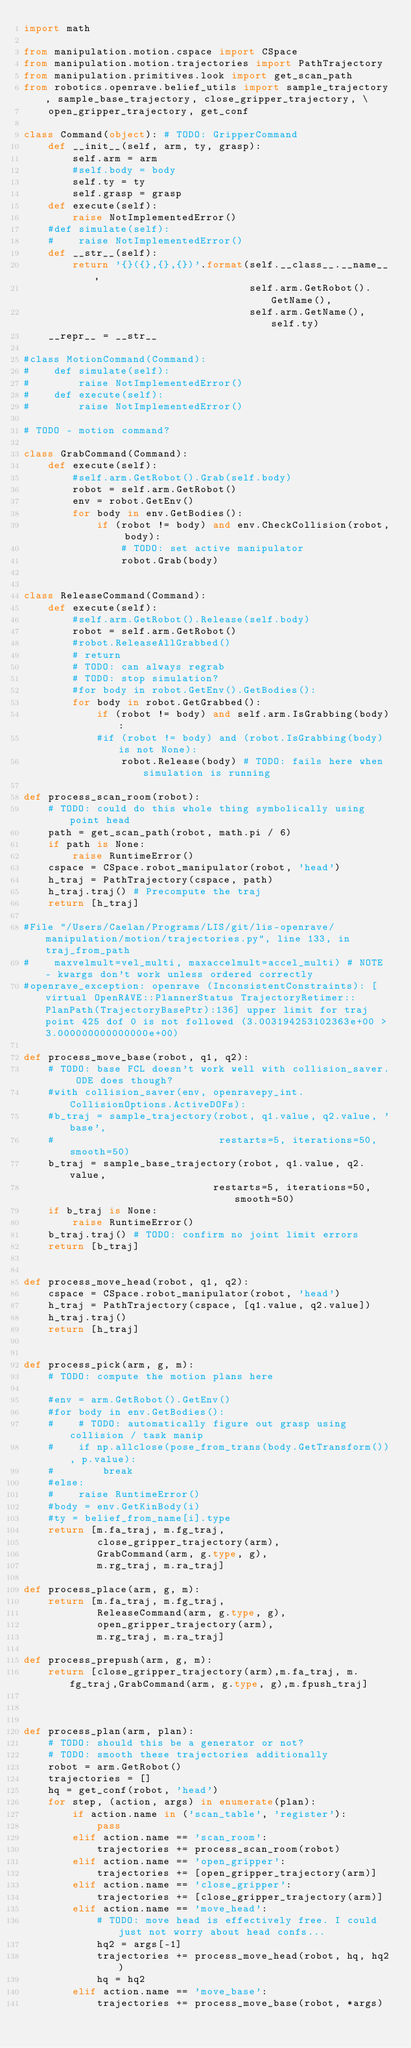<code> <loc_0><loc_0><loc_500><loc_500><_Python_>import math

from manipulation.motion.cspace import CSpace
from manipulation.motion.trajectories import PathTrajectory
from manipulation.primitives.look import get_scan_path
from robotics.openrave.belief_utils import sample_trajectory, sample_base_trajectory, close_gripper_trajectory, \
    open_gripper_trajectory, get_conf

class Command(object): # TODO: GripperCommand
    def __init__(self, arm, ty, grasp):
        self.arm = arm
        #self.body = body
        self.ty = ty
        self.grasp = grasp
    def execute(self):
        raise NotImplementedError()
    #def simulate(self):
    #    raise NotImplementedError()
    def __str__(self):
        return '{}({},{},{})'.format(self.__class__.__name__,
                                     self.arm.GetRobot().GetName(),
                                     self.arm.GetName(), self.ty)
    __repr__ = __str__

#class MotionCommand(Command):
#    def simulate(self):
#        raise NotImplementedError()
#    def execute(self):
#        raise NotImplementedError()

# TODO - motion command?

class GrabCommand(Command):
    def execute(self):
        #self.arm.GetRobot().Grab(self.body)
        robot = self.arm.GetRobot()
        env = robot.GetEnv()
        for body in env.GetBodies():
            if (robot != body) and env.CheckCollision(robot, body):
                # TODO: set active manipulator
                robot.Grab(body)


class ReleaseCommand(Command):
    def execute(self):
        #self.arm.GetRobot().Release(self.body)
        robot = self.arm.GetRobot()
        #robot.ReleaseAllGrabbed()
        # return
        # TODO: can always regrab
        # TODO: stop simulation?
        #for body in robot.GetEnv().GetBodies():
        for body in robot.GetGrabbed():
            if (robot != body) and self.arm.IsGrabbing(body):
            #if (robot != body) and (robot.IsGrabbing(body) is not None):
                robot.Release(body) # TODO: fails here when simulation is running

def process_scan_room(robot):
    # TODO: could do this whole thing symbolically using point head
    path = get_scan_path(robot, math.pi / 6)
    if path is None:
        raise RuntimeError()
    cspace = CSpace.robot_manipulator(robot, 'head')
    h_traj = PathTrajectory(cspace, path)
    h_traj.traj() # Precompute the traj
    return [h_traj]

#File "/Users/Caelan/Programs/LIS/git/lis-openrave/manipulation/motion/trajectories.py", line 133, in traj_from_path
#    maxvelmult=vel_multi, maxaccelmult=accel_multi) # NOTE - kwargs don't work unless ordered correctly
#openrave_exception: openrave (InconsistentConstraints): [virtual OpenRAVE::PlannerStatus TrajectoryRetimer::PlanPath(TrajectoryBasePtr):136] upper limit for traj point 425 dof 0 is not followed (3.003194253102363e+00 > 3.000000000000000e+00)

def process_move_base(robot, q1, q2):
    # TODO: base FCL doesn't work well with collision_saver. ODE does though?
    #with collision_saver(env, openravepy_int.CollisionOptions.ActiveDOFs):
    #b_traj = sample_trajectory(robot, q1.value, q2.value, 'base',
    #                           restarts=5, iterations=50, smooth=50)
    b_traj = sample_base_trajectory(robot, q1.value, q2.value,
                               restarts=5, iterations=50, smooth=50)
    if b_traj is None:
        raise RuntimeError()
    b_traj.traj() # TODO: confirm no joint limit errors
    return [b_traj]


def process_move_head(robot, q1, q2):
    cspace = CSpace.robot_manipulator(robot, 'head')
    h_traj = PathTrajectory(cspace, [q1.value, q2.value])
    h_traj.traj()
    return [h_traj]


def process_pick(arm, g, m):
    # TODO: compute the motion plans here

    #env = arm.GetRobot().GetEnv()
    #for body in env.GetBodies():
    #    # TODO: automatically figure out grasp using collision / task manip
    #    if np.allclose(pose_from_trans(body.GetTransform()), p.value):
    #        break
    #else:
    #    raise RuntimeError()
    #body = env.GetKinBody(i)
    #ty = belief_from_name[i].type
    return [m.fa_traj, m.fg_traj,
            close_gripper_trajectory(arm),
            GrabCommand(arm, g.type, g),
            m.rg_traj, m.ra_traj]

def process_place(arm, g, m):
    return [m.fa_traj, m.fg_traj,
            ReleaseCommand(arm, g.type, g),
            open_gripper_trajectory(arm),
            m.rg_traj, m.ra_traj]

def process_prepush(arm, g, m):
    return [close_gripper_trajectory(arm),m.fa_traj, m.fg_traj,GrabCommand(arm, g.type, g),m.fpush_traj]



def process_plan(arm, plan):
    # TODO: should this be a generator or not?
    # TODO: smooth these trajectories additionally
    robot = arm.GetRobot()
    trajectories = []
    hq = get_conf(robot, 'head')
    for step, (action, args) in enumerate(plan):
        if action.name in ('scan_table', 'register'):
            pass
        elif action.name == 'scan_room':
            trajectories += process_scan_room(robot)
        elif action.name == 'open_gripper':
            trajectories += [open_gripper_trajectory(arm)]
        elif action.name == 'close_gripper':
            trajectories += [close_gripper_trajectory(arm)]
        elif action.name == 'move_head':
            # TODO: move head is effectively free. I could just not worry about head confs...
            hq2 = args[-1]
            trajectories += process_move_head(robot, hq, hq2)
            hq = hq2
        elif action.name == 'move_base':
            trajectories += process_move_base(robot, *args)</code> 